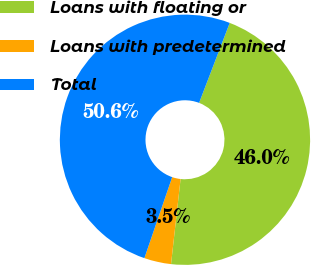Convert chart. <chart><loc_0><loc_0><loc_500><loc_500><pie_chart><fcel>Loans with floating or<fcel>Loans with predetermined<fcel>Total<nl><fcel>45.96%<fcel>3.48%<fcel>50.56%<nl></chart> 